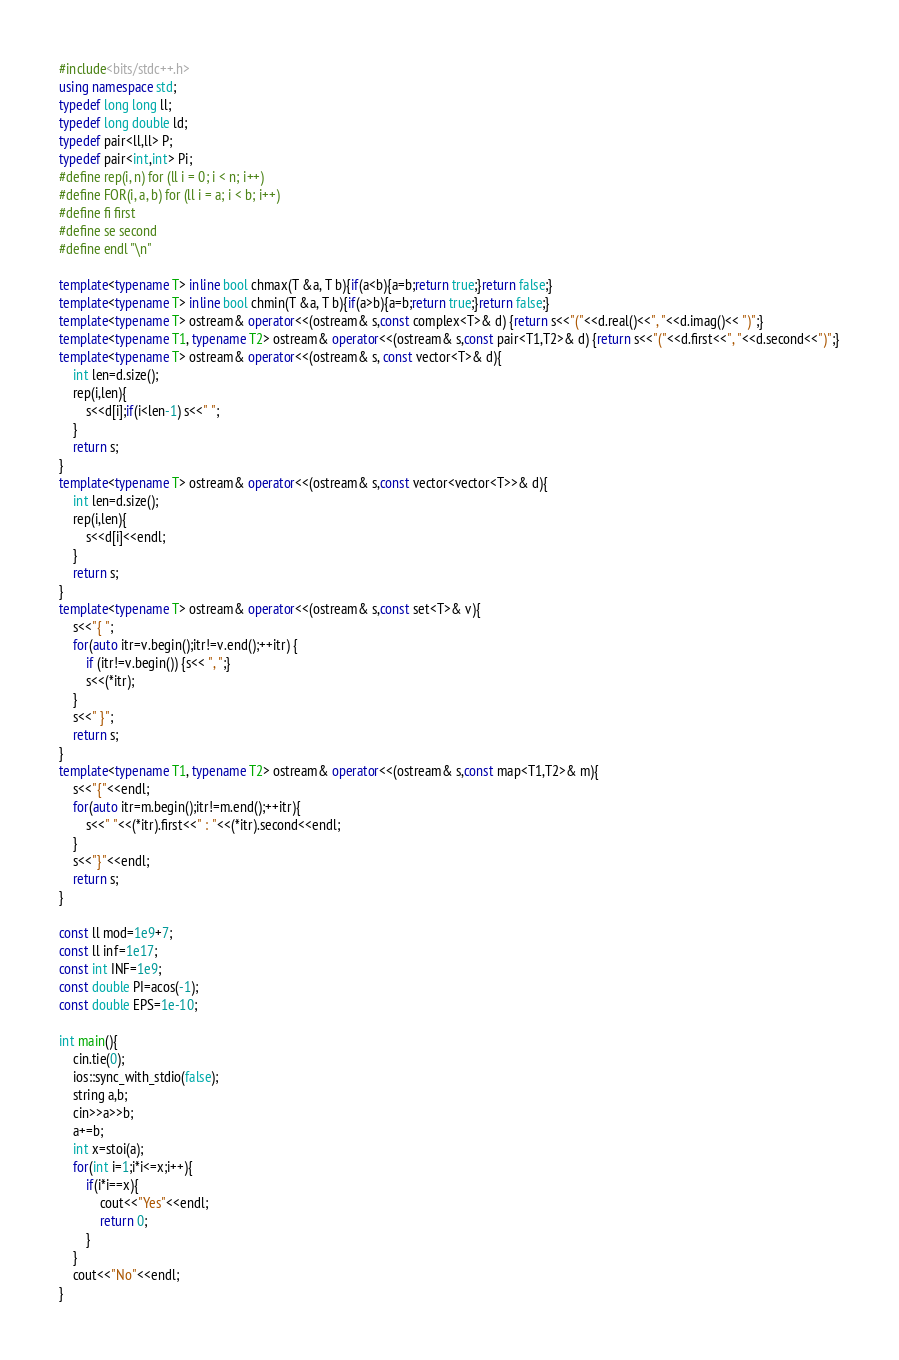<code> <loc_0><loc_0><loc_500><loc_500><_C++_>#include<bits/stdc++.h>
using namespace std;
typedef long long ll;
typedef long double ld;
typedef pair<ll,ll> P;
typedef pair<int,int> Pi;
#define rep(i, n) for (ll i = 0; i < n; i++)
#define FOR(i, a, b) for (ll i = a; i < b; i++)
#define fi first
#define se second
#define endl "\n"

template<typename T> inline bool chmax(T &a, T b){if(a<b){a=b;return true;}return false;}
template<typename T> inline bool chmin(T &a, T b){if(a>b){a=b;return true;}return false;}
template<typename T> ostream& operator<<(ostream& s,const complex<T>& d) {return s<<"("<<d.real()<<", "<<d.imag()<< ")";}
template<typename T1, typename T2> ostream& operator<<(ostream& s,const pair<T1,T2>& d) {return s<<"("<<d.first<<", "<<d.second<<")";}
template<typename T> ostream& operator<<(ostream& s, const vector<T>& d){
	int len=d.size();
	rep(i,len){
		s<<d[i];if(i<len-1) s<<" ";
	}
	return s;
}
template<typename T> ostream& operator<<(ostream& s,const vector<vector<T>>& d){
	int len=d.size();
	rep(i,len){
		s<<d[i]<<endl;
	}
	return s;
}
template<typename T> ostream& operator<<(ostream& s,const set<T>& v){
	s<<"{ ";
	for(auto itr=v.begin();itr!=v.end();++itr) {
		if (itr!=v.begin()) {s<< ", ";}
		s<<(*itr);
	}
	s<<" }";
	return s;
}
template<typename T1, typename T2> ostream& operator<<(ostream& s,const map<T1,T2>& m){
	s<<"{"<<endl;
	for(auto itr=m.begin();itr!=m.end();++itr){
		s<<" "<<(*itr).first<<" : "<<(*itr).second<<endl;
	}
	s<<"}"<<endl;
	return s;
}

const ll mod=1e9+7;
const ll inf=1e17;
const int INF=1e9;
const double PI=acos(-1);
const double EPS=1e-10;

int main(){
	cin.tie(0);
	ios::sync_with_stdio(false);
	string a,b;
	cin>>a>>b;
	a+=b;
	int x=stoi(a);
	for(int i=1;i*i<=x;i++){
		if(i*i==x){
			cout<<"Yes"<<endl;
			return 0;
		}
	}
	cout<<"No"<<endl;
}</code> 